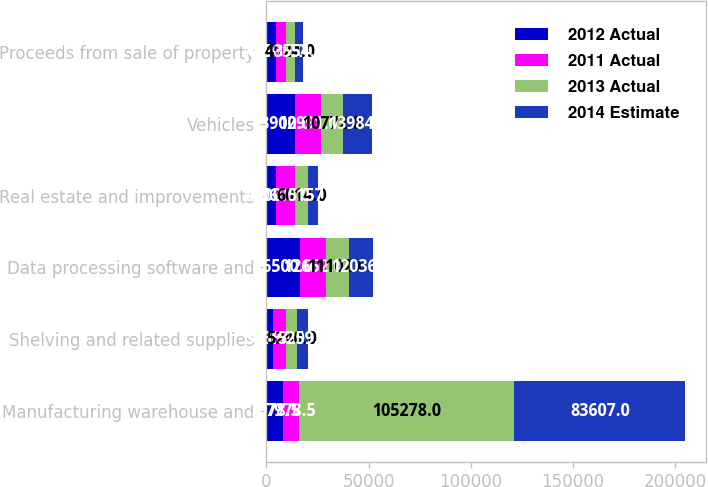Convert chart to OTSL. <chart><loc_0><loc_0><loc_500><loc_500><stacked_bar_chart><ecel><fcel>Manufacturing warehouse and<fcel>Shelving and related supplies<fcel>Data processing software and<fcel>Real estate and improvements<fcel>Vehicles<fcel>Proceeds from sale of property<nl><fcel>2012 Actual<fcel>7978.5<fcel>3400<fcel>16500<fcel>4500<fcel>13900<fcel>4600<nl><fcel>2011 Actual<fcel>7978.5<fcel>6354<fcel>12652<fcel>9603<fcel>12991<fcel>4990<nl><fcel>2013 Actual<fcel>105278<fcel>5240<fcel>11102<fcel>6014<fcel>10772<fcel>4524<nl><fcel>2014 Estimate<fcel>83607<fcel>5259<fcel>12036<fcel>5157<fcel>13984<fcel>3554<nl></chart> 